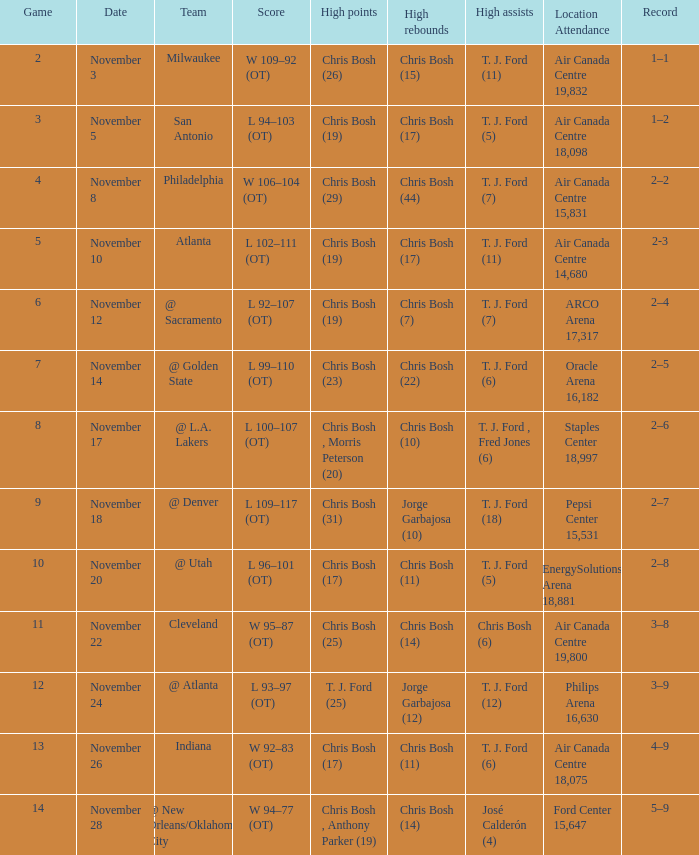Who scored the most points in game 4? Chris Bosh (29). Would you be able to parse every entry in this table? {'header': ['Game', 'Date', 'Team', 'Score', 'High points', 'High rebounds', 'High assists', 'Location Attendance', 'Record'], 'rows': [['2', 'November 3', 'Milwaukee', 'W 109–92 (OT)', 'Chris Bosh (26)', 'Chris Bosh (15)', 'T. J. Ford (11)', 'Air Canada Centre 19,832', '1–1'], ['3', 'November 5', 'San Antonio', 'L 94–103 (OT)', 'Chris Bosh (19)', 'Chris Bosh (17)', 'T. J. Ford (5)', 'Air Canada Centre 18,098', '1–2'], ['4', 'November 8', 'Philadelphia', 'W 106–104 (OT)', 'Chris Bosh (29)', 'Chris Bosh (44)', 'T. J. Ford (7)', 'Air Canada Centre 15,831', '2–2'], ['5', 'November 10', 'Atlanta', 'L 102–111 (OT)', 'Chris Bosh (19)', 'Chris Bosh (17)', 'T. J. Ford (11)', 'Air Canada Centre 14,680', '2-3'], ['6', 'November 12', '@ Sacramento', 'L 92–107 (OT)', 'Chris Bosh (19)', 'Chris Bosh (7)', 'T. J. Ford (7)', 'ARCO Arena 17,317', '2–4'], ['7', 'November 14', '@ Golden State', 'L 99–110 (OT)', 'Chris Bosh (23)', 'Chris Bosh (22)', 'T. J. Ford (6)', 'Oracle Arena 16,182', '2–5'], ['8', 'November 17', '@ L.A. Lakers', 'L 100–107 (OT)', 'Chris Bosh , Morris Peterson (20)', 'Chris Bosh (10)', 'T. J. Ford , Fred Jones (6)', 'Staples Center 18,997', '2–6'], ['9', 'November 18', '@ Denver', 'L 109–117 (OT)', 'Chris Bosh (31)', 'Jorge Garbajosa (10)', 'T. J. Ford (18)', 'Pepsi Center 15,531', '2–7'], ['10', 'November 20', '@ Utah', 'L 96–101 (OT)', 'Chris Bosh (17)', 'Chris Bosh (11)', 'T. J. Ford (5)', 'EnergySolutions Arena 18,881', '2–8'], ['11', 'November 22', 'Cleveland', 'W 95–87 (OT)', 'Chris Bosh (25)', 'Chris Bosh (14)', 'Chris Bosh (6)', 'Air Canada Centre 19,800', '3–8'], ['12', 'November 24', '@ Atlanta', 'L 93–97 (OT)', 'T. J. Ford (25)', 'Jorge Garbajosa (12)', 'T. J. Ford (12)', 'Philips Arena 16,630', '3–9'], ['13', 'November 26', 'Indiana', 'W 92–83 (OT)', 'Chris Bosh (17)', 'Chris Bosh (11)', 'T. J. Ford (6)', 'Air Canada Centre 18,075', '4–9'], ['14', 'November 28', '@ New Orleans/Oklahoma City', 'W 94–77 (OT)', 'Chris Bosh , Anthony Parker (19)', 'Chris Bosh (14)', 'José Calderón (4)', 'Ford Center 15,647', '5–9']]} 